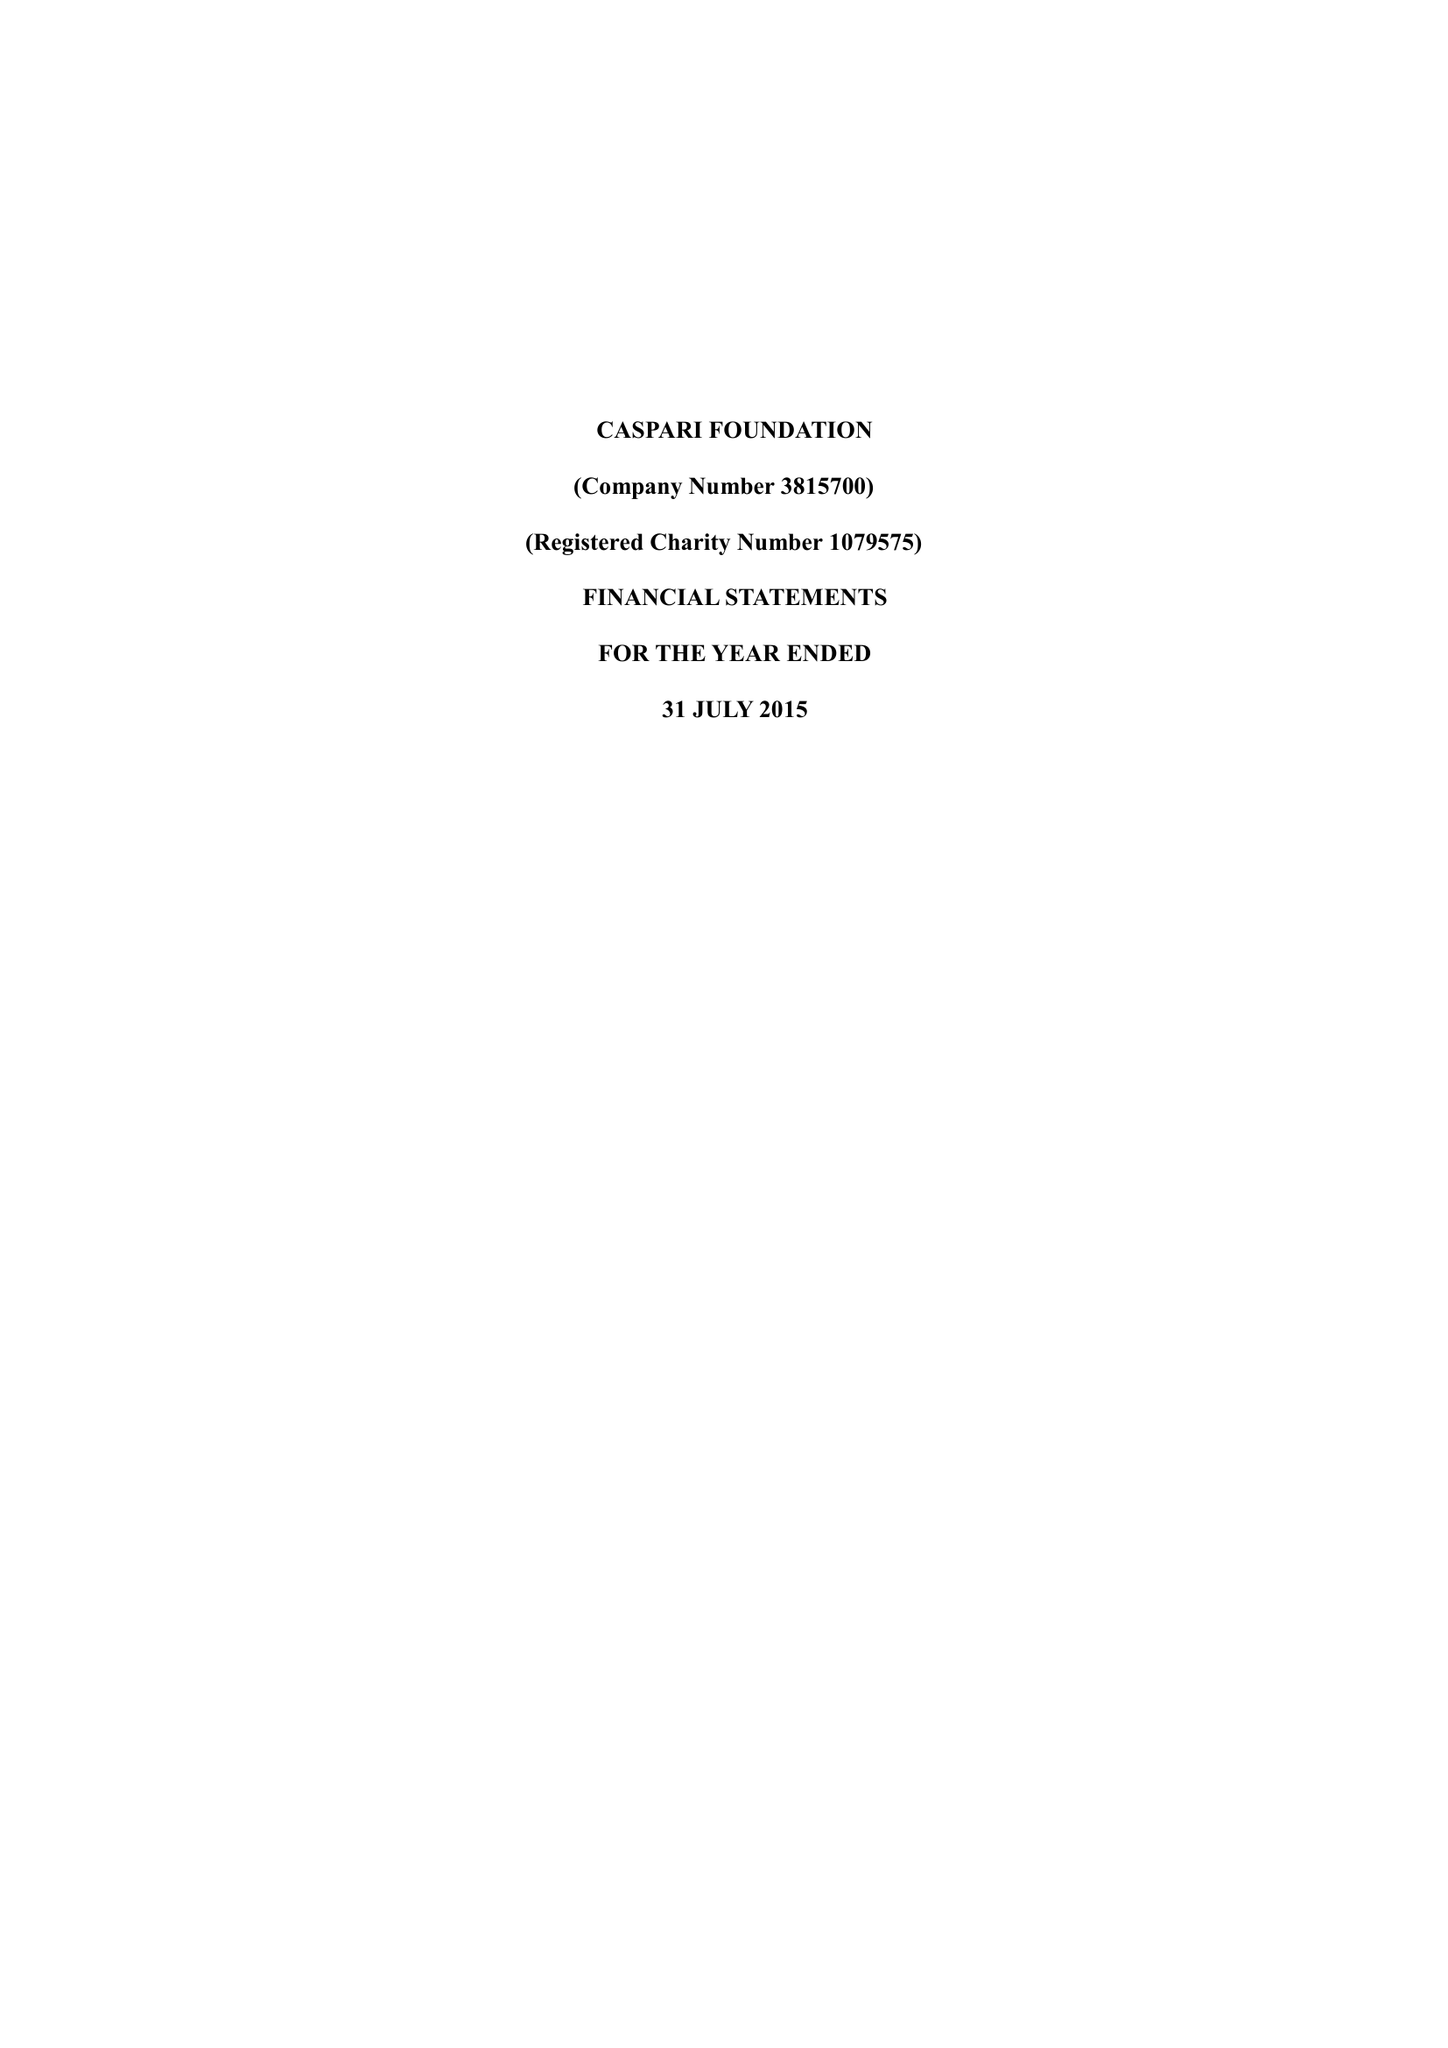What is the value for the income_annually_in_british_pounds?
Answer the question using a single word or phrase. 80381.00 